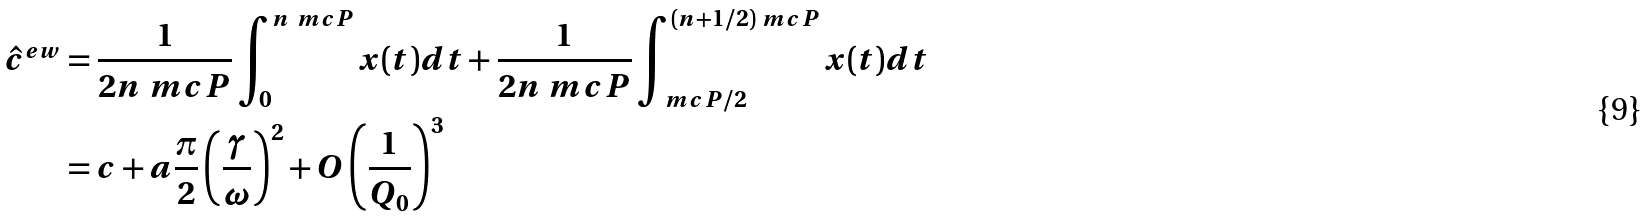<formula> <loc_0><loc_0><loc_500><loc_500>\hat { c } ^ { e w } & = \frac { 1 } { 2 n \ m c { P } } \int _ { 0 } ^ { n \ m c { P } } x ( t ) d t + \frac { 1 } { 2 n \ m c { P } } \int _ { \ m c { P } / 2 } ^ { ( n + 1 / 2 ) \ m c { P } } x ( t ) d t \\ & = c + a \frac { \pi } { 2 } \left ( \frac { \gamma } { \omega } \right ) ^ { 2 } + O \left ( \frac { 1 } { Q _ { 0 } } \right ) ^ { 3 }</formula> 